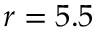<formula> <loc_0><loc_0><loc_500><loc_500>r = 5 . 5</formula> 